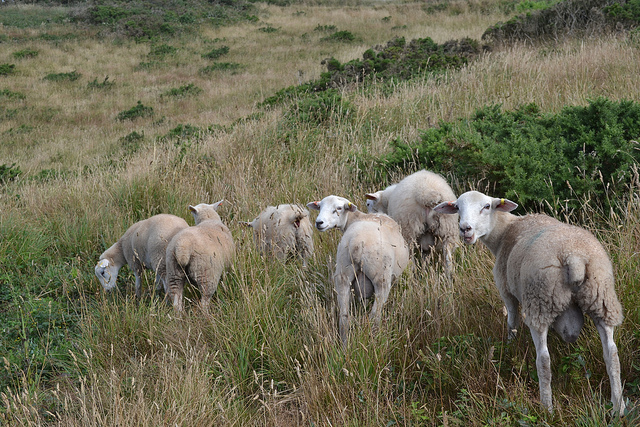<image>Which one of these sheep is a baby? It's ambiguous which of these sheep is a baby since some answers indicate there isn't a baby sheep and others point out different sheep. Which one of these sheep is a baby? I am not sure which one of these sheep is a baby. It can be any of them or none of them. 